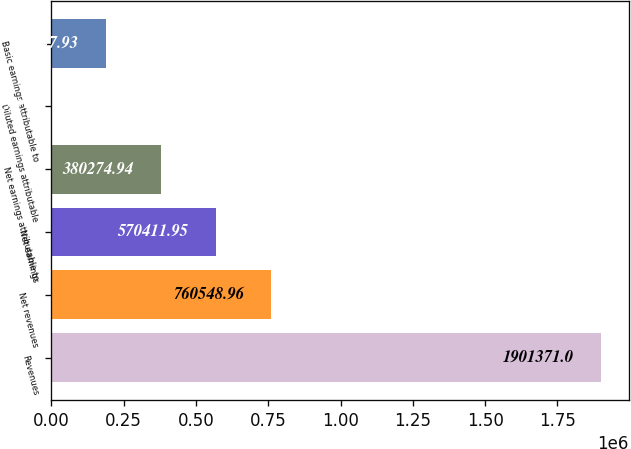<chart> <loc_0><loc_0><loc_500><loc_500><bar_chart><fcel>Revenues<fcel>Net revenues<fcel>Net earnings<fcel>Net earnings attributable to<fcel>Diluted earnings attributable<fcel>Basic earnings attributable to<nl><fcel>1.90137e+06<fcel>760549<fcel>570412<fcel>380275<fcel>0.92<fcel>190138<nl></chart> 